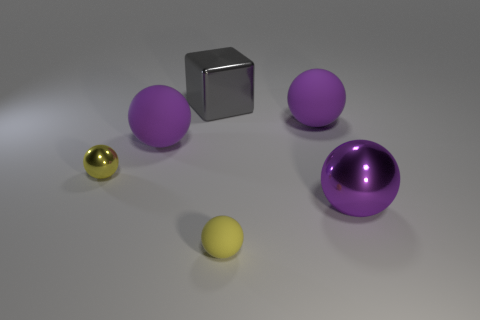Can you tell me what objects are present in the image, along with their colors and materials? Certainly! The image depicts five objects on a flat surface. Starting from the left, there is a small, shiny golden sphere, likely made of metal. Next is a small, matte grey cube, which appears to be made of rubber. Following these, there are three spheres. The foremost sphere is small and yellow, with a reflective metallic surface. Behind it, there are two larger spheres; both are matte and purple in color. 